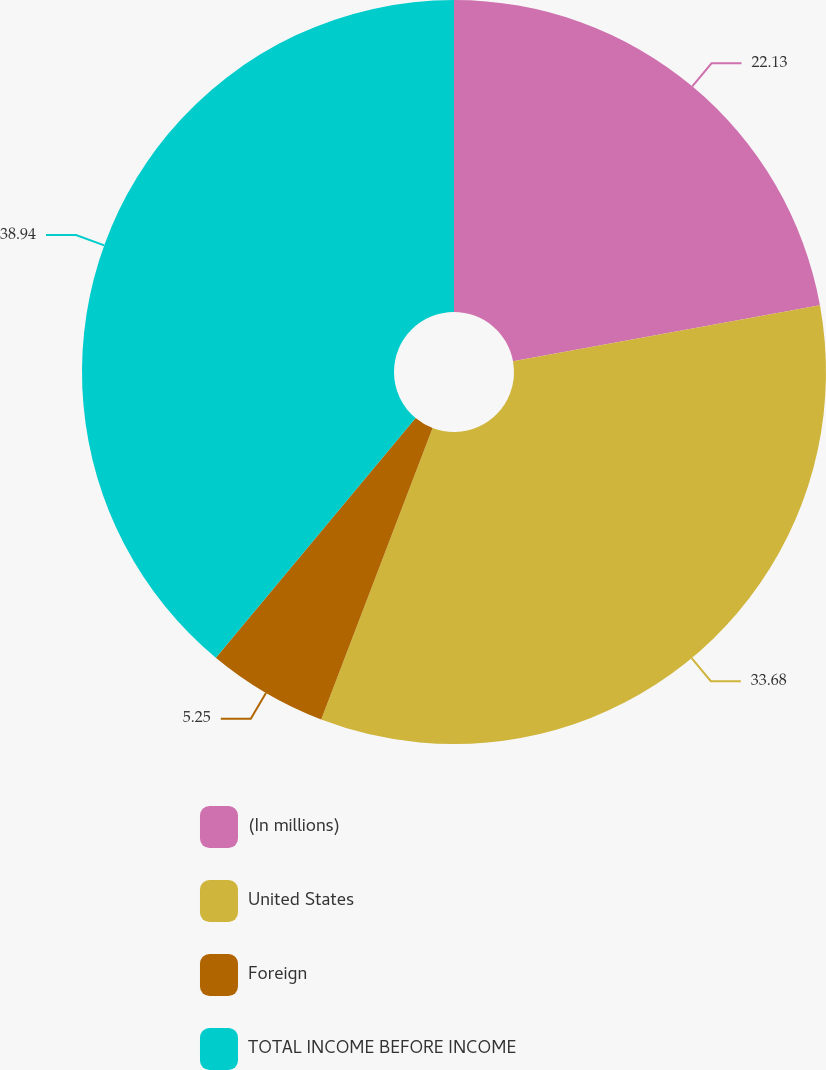Convert chart to OTSL. <chart><loc_0><loc_0><loc_500><loc_500><pie_chart><fcel>(In millions)<fcel>United States<fcel>Foreign<fcel>TOTAL INCOME BEFORE INCOME<nl><fcel>22.13%<fcel>33.68%<fcel>5.25%<fcel>38.94%<nl></chart> 